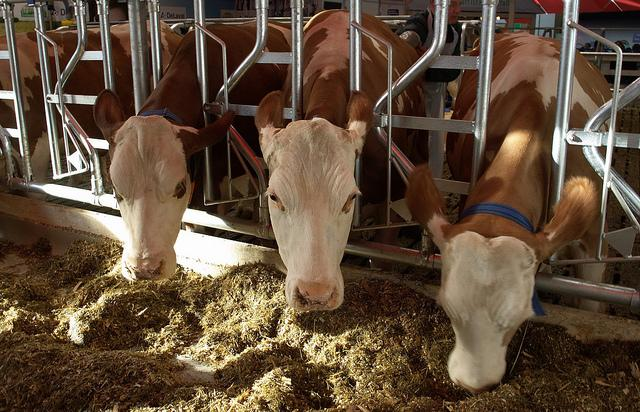Why are the animals putting their face to the ground?

Choices:
A) to rest
B) to sleep
C) to eat
D) to fight to eat 